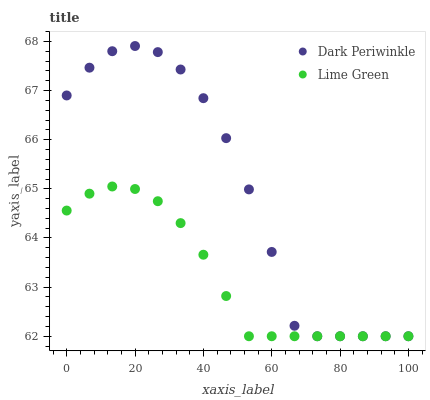Does Lime Green have the minimum area under the curve?
Answer yes or no. Yes. Does Dark Periwinkle have the maximum area under the curve?
Answer yes or no. Yes. Does Dark Periwinkle have the minimum area under the curve?
Answer yes or no. No. Is Lime Green the smoothest?
Answer yes or no. Yes. Is Dark Periwinkle the roughest?
Answer yes or no. Yes. Is Dark Periwinkle the smoothest?
Answer yes or no. No. Does Lime Green have the lowest value?
Answer yes or no. Yes. Does Dark Periwinkle have the highest value?
Answer yes or no. Yes. Does Dark Periwinkle intersect Lime Green?
Answer yes or no. Yes. Is Dark Periwinkle less than Lime Green?
Answer yes or no. No. Is Dark Periwinkle greater than Lime Green?
Answer yes or no. No. 